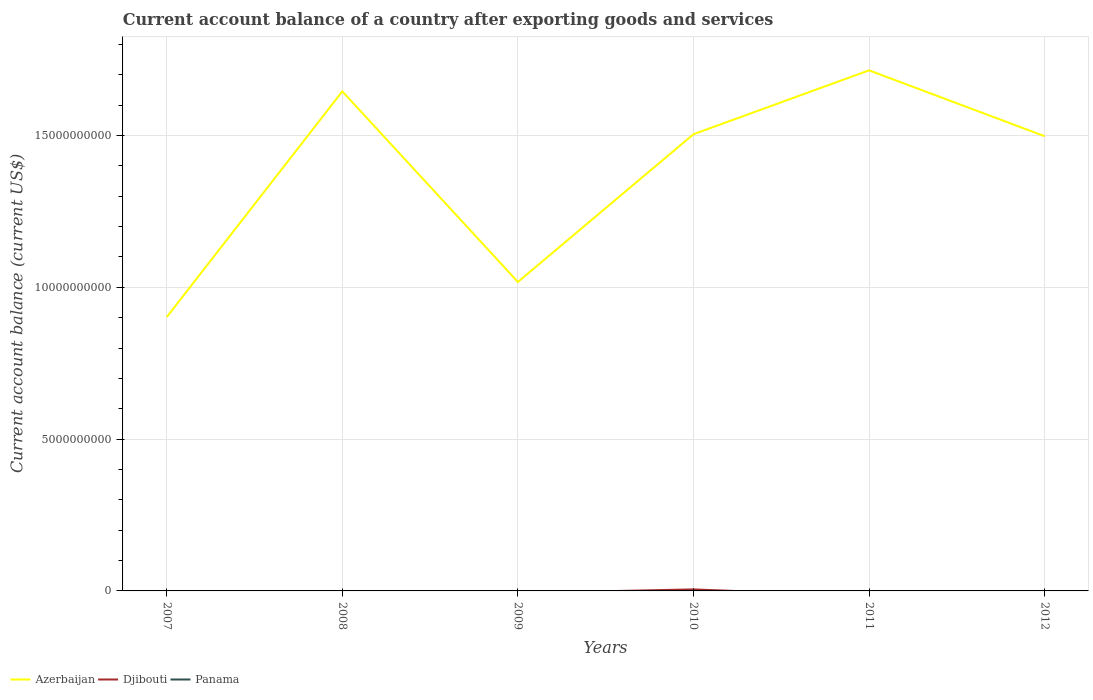How many different coloured lines are there?
Your answer should be compact. 2. Is the number of lines equal to the number of legend labels?
Make the answer very short. No. Across all years, what is the maximum account balance in Azerbaijan?
Provide a short and direct response. 9.02e+09. What is the total account balance in Azerbaijan in the graph?
Your answer should be very brief. -6.97e+09. What is the difference between the highest and the second highest account balance in Djibouti?
Provide a short and direct response. 5.05e+07. Is the account balance in Azerbaijan strictly greater than the account balance in Djibouti over the years?
Your answer should be compact. No. How many years are there in the graph?
Provide a short and direct response. 6. Are the values on the major ticks of Y-axis written in scientific E-notation?
Give a very brief answer. No. Does the graph contain any zero values?
Give a very brief answer. Yes. Where does the legend appear in the graph?
Keep it short and to the point. Bottom left. How many legend labels are there?
Make the answer very short. 3. What is the title of the graph?
Provide a succinct answer. Current account balance of a country after exporting goods and services. Does "Jamaica" appear as one of the legend labels in the graph?
Keep it short and to the point. No. What is the label or title of the Y-axis?
Offer a very short reply. Current account balance (current US$). What is the Current account balance (current US$) in Azerbaijan in 2007?
Give a very brief answer. 9.02e+09. What is the Current account balance (current US$) in Djibouti in 2007?
Your answer should be very brief. 0. What is the Current account balance (current US$) in Azerbaijan in 2008?
Ensure brevity in your answer.  1.65e+1. What is the Current account balance (current US$) in Azerbaijan in 2009?
Give a very brief answer. 1.02e+1. What is the Current account balance (current US$) of Azerbaijan in 2010?
Offer a very short reply. 1.50e+1. What is the Current account balance (current US$) of Djibouti in 2010?
Your answer should be compact. 5.05e+07. What is the Current account balance (current US$) of Azerbaijan in 2011?
Keep it short and to the point. 1.71e+1. What is the Current account balance (current US$) of Djibouti in 2011?
Your answer should be compact. 0. What is the Current account balance (current US$) in Azerbaijan in 2012?
Provide a succinct answer. 1.50e+1. What is the Current account balance (current US$) in Panama in 2012?
Make the answer very short. 0. Across all years, what is the maximum Current account balance (current US$) in Azerbaijan?
Ensure brevity in your answer.  1.71e+1. Across all years, what is the maximum Current account balance (current US$) of Djibouti?
Offer a terse response. 5.05e+07. Across all years, what is the minimum Current account balance (current US$) of Azerbaijan?
Offer a terse response. 9.02e+09. Across all years, what is the minimum Current account balance (current US$) in Djibouti?
Your answer should be very brief. 0. What is the total Current account balance (current US$) in Azerbaijan in the graph?
Your answer should be compact. 8.28e+1. What is the total Current account balance (current US$) of Djibouti in the graph?
Ensure brevity in your answer.  5.05e+07. What is the difference between the Current account balance (current US$) of Azerbaijan in 2007 and that in 2008?
Keep it short and to the point. -7.43e+09. What is the difference between the Current account balance (current US$) of Azerbaijan in 2007 and that in 2009?
Provide a short and direct response. -1.16e+09. What is the difference between the Current account balance (current US$) in Azerbaijan in 2007 and that in 2010?
Ensure brevity in your answer.  -6.02e+09. What is the difference between the Current account balance (current US$) of Azerbaijan in 2007 and that in 2011?
Your answer should be compact. -8.13e+09. What is the difference between the Current account balance (current US$) of Azerbaijan in 2007 and that in 2012?
Provide a short and direct response. -5.96e+09. What is the difference between the Current account balance (current US$) in Azerbaijan in 2008 and that in 2009?
Your answer should be compact. 6.28e+09. What is the difference between the Current account balance (current US$) of Azerbaijan in 2008 and that in 2010?
Your response must be concise. 1.41e+09. What is the difference between the Current account balance (current US$) of Azerbaijan in 2008 and that in 2011?
Provide a short and direct response. -6.92e+08. What is the difference between the Current account balance (current US$) in Azerbaijan in 2008 and that in 2012?
Make the answer very short. 1.48e+09. What is the difference between the Current account balance (current US$) of Azerbaijan in 2009 and that in 2010?
Give a very brief answer. -4.87e+09. What is the difference between the Current account balance (current US$) of Azerbaijan in 2009 and that in 2011?
Provide a succinct answer. -6.97e+09. What is the difference between the Current account balance (current US$) of Azerbaijan in 2009 and that in 2012?
Your answer should be compact. -4.80e+09. What is the difference between the Current account balance (current US$) in Azerbaijan in 2010 and that in 2011?
Ensure brevity in your answer.  -2.10e+09. What is the difference between the Current account balance (current US$) in Azerbaijan in 2010 and that in 2012?
Provide a succinct answer. 6.44e+07. What is the difference between the Current account balance (current US$) in Azerbaijan in 2011 and that in 2012?
Offer a terse response. 2.17e+09. What is the difference between the Current account balance (current US$) in Azerbaijan in 2007 and the Current account balance (current US$) in Djibouti in 2010?
Make the answer very short. 8.97e+09. What is the difference between the Current account balance (current US$) of Azerbaijan in 2008 and the Current account balance (current US$) of Djibouti in 2010?
Your answer should be compact. 1.64e+1. What is the difference between the Current account balance (current US$) of Azerbaijan in 2009 and the Current account balance (current US$) of Djibouti in 2010?
Your answer should be very brief. 1.01e+1. What is the average Current account balance (current US$) in Azerbaijan per year?
Your answer should be compact. 1.38e+1. What is the average Current account balance (current US$) of Djibouti per year?
Ensure brevity in your answer.  8.41e+06. What is the average Current account balance (current US$) of Panama per year?
Provide a short and direct response. 0. In the year 2010, what is the difference between the Current account balance (current US$) of Azerbaijan and Current account balance (current US$) of Djibouti?
Give a very brief answer. 1.50e+1. What is the ratio of the Current account balance (current US$) of Azerbaijan in 2007 to that in 2008?
Make the answer very short. 0.55. What is the ratio of the Current account balance (current US$) of Azerbaijan in 2007 to that in 2009?
Make the answer very short. 0.89. What is the ratio of the Current account balance (current US$) in Azerbaijan in 2007 to that in 2010?
Ensure brevity in your answer.  0.6. What is the ratio of the Current account balance (current US$) in Azerbaijan in 2007 to that in 2011?
Your answer should be very brief. 0.53. What is the ratio of the Current account balance (current US$) of Azerbaijan in 2007 to that in 2012?
Offer a very short reply. 0.6. What is the ratio of the Current account balance (current US$) in Azerbaijan in 2008 to that in 2009?
Keep it short and to the point. 1.62. What is the ratio of the Current account balance (current US$) in Azerbaijan in 2008 to that in 2010?
Your answer should be compact. 1.09. What is the ratio of the Current account balance (current US$) in Azerbaijan in 2008 to that in 2011?
Offer a terse response. 0.96. What is the ratio of the Current account balance (current US$) in Azerbaijan in 2008 to that in 2012?
Offer a very short reply. 1.1. What is the ratio of the Current account balance (current US$) of Azerbaijan in 2009 to that in 2010?
Offer a very short reply. 0.68. What is the ratio of the Current account balance (current US$) of Azerbaijan in 2009 to that in 2011?
Provide a short and direct response. 0.59. What is the ratio of the Current account balance (current US$) in Azerbaijan in 2009 to that in 2012?
Provide a short and direct response. 0.68. What is the ratio of the Current account balance (current US$) in Azerbaijan in 2010 to that in 2011?
Your response must be concise. 0.88. What is the ratio of the Current account balance (current US$) in Azerbaijan in 2010 to that in 2012?
Your answer should be compact. 1. What is the ratio of the Current account balance (current US$) of Azerbaijan in 2011 to that in 2012?
Provide a succinct answer. 1.14. What is the difference between the highest and the second highest Current account balance (current US$) of Azerbaijan?
Ensure brevity in your answer.  6.92e+08. What is the difference between the highest and the lowest Current account balance (current US$) of Azerbaijan?
Offer a terse response. 8.13e+09. What is the difference between the highest and the lowest Current account balance (current US$) of Djibouti?
Keep it short and to the point. 5.05e+07. 